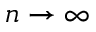Convert formula to latex. <formula><loc_0><loc_0><loc_500><loc_500>n \rightarrow \infty</formula> 